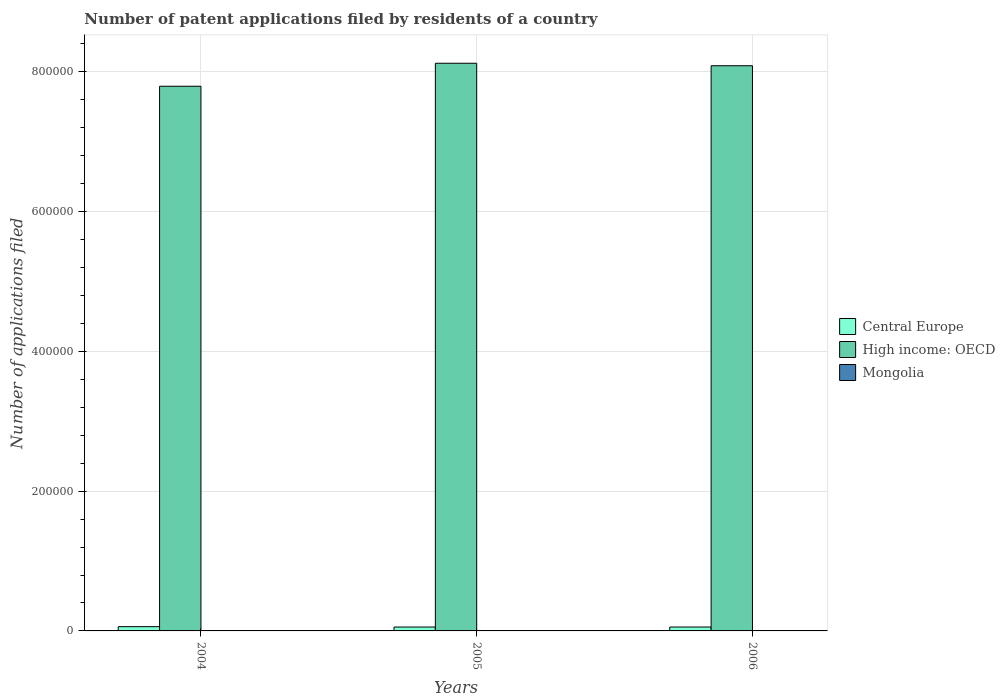How many different coloured bars are there?
Offer a very short reply. 3. How many groups of bars are there?
Provide a short and direct response. 3. Are the number of bars per tick equal to the number of legend labels?
Your response must be concise. Yes. Are the number of bars on each tick of the X-axis equal?
Give a very brief answer. Yes. How many bars are there on the 1st tick from the left?
Offer a terse response. 3. How many bars are there on the 1st tick from the right?
Your answer should be compact. 3. What is the label of the 3rd group of bars from the left?
Ensure brevity in your answer.  2006. In how many cases, is the number of bars for a given year not equal to the number of legend labels?
Provide a short and direct response. 0. What is the number of applications filed in Mongolia in 2004?
Your answer should be compact. 143. Across all years, what is the maximum number of applications filed in High income: OECD?
Your answer should be very brief. 8.12e+05. Across all years, what is the minimum number of applications filed in High income: OECD?
Your answer should be compact. 7.79e+05. In which year was the number of applications filed in Mongolia maximum?
Offer a terse response. 2004. What is the total number of applications filed in High income: OECD in the graph?
Provide a succinct answer. 2.40e+06. What is the difference between the number of applications filed in High income: OECD in 2005 and that in 2006?
Make the answer very short. 3553. What is the difference between the number of applications filed in Central Europe in 2005 and the number of applications filed in High income: OECD in 2004?
Make the answer very short. -7.74e+05. What is the average number of applications filed in High income: OECD per year?
Give a very brief answer. 8.00e+05. In the year 2006, what is the difference between the number of applications filed in High income: OECD and number of applications filed in Mongolia?
Provide a succinct answer. 8.09e+05. In how many years, is the number of applications filed in Mongolia greater than 800000?
Keep it short and to the point. 0. What is the ratio of the number of applications filed in High income: OECD in 2004 to that in 2006?
Your answer should be compact. 0.96. Is the difference between the number of applications filed in High income: OECD in 2004 and 2006 greater than the difference between the number of applications filed in Mongolia in 2004 and 2006?
Offer a terse response. No. What is the difference between the highest and the lowest number of applications filed in Central Europe?
Keep it short and to the point. 538. In how many years, is the number of applications filed in High income: OECD greater than the average number of applications filed in High income: OECD taken over all years?
Offer a terse response. 2. Is the sum of the number of applications filed in Mongolia in 2004 and 2005 greater than the maximum number of applications filed in Central Europe across all years?
Your answer should be compact. No. What does the 1st bar from the left in 2006 represents?
Offer a very short reply. Central Europe. What does the 2nd bar from the right in 2005 represents?
Provide a succinct answer. High income: OECD. Does the graph contain grids?
Offer a very short reply. Yes. Where does the legend appear in the graph?
Your answer should be compact. Center right. How many legend labels are there?
Offer a very short reply. 3. How are the legend labels stacked?
Offer a terse response. Vertical. What is the title of the graph?
Make the answer very short. Number of patent applications filed by residents of a country. Does "Lebanon" appear as one of the legend labels in the graph?
Offer a terse response. No. What is the label or title of the Y-axis?
Your answer should be very brief. Number of applications filed. What is the Number of applications filed of Central Europe in 2004?
Give a very brief answer. 6099. What is the Number of applications filed in High income: OECD in 2004?
Make the answer very short. 7.79e+05. What is the Number of applications filed in Mongolia in 2004?
Make the answer very short. 143. What is the Number of applications filed in Central Europe in 2005?
Your answer should be very brief. 5561. What is the Number of applications filed of High income: OECD in 2005?
Provide a succinct answer. 8.12e+05. What is the Number of applications filed in Mongolia in 2005?
Ensure brevity in your answer.  100. What is the Number of applications filed in Central Europe in 2006?
Offer a very short reply. 5585. What is the Number of applications filed in High income: OECD in 2006?
Offer a terse response. 8.09e+05. What is the Number of applications filed of Mongolia in 2006?
Give a very brief answer. 103. Across all years, what is the maximum Number of applications filed in Central Europe?
Give a very brief answer. 6099. Across all years, what is the maximum Number of applications filed of High income: OECD?
Give a very brief answer. 8.12e+05. Across all years, what is the maximum Number of applications filed in Mongolia?
Provide a short and direct response. 143. Across all years, what is the minimum Number of applications filed in Central Europe?
Keep it short and to the point. 5561. Across all years, what is the minimum Number of applications filed in High income: OECD?
Make the answer very short. 7.79e+05. What is the total Number of applications filed in Central Europe in the graph?
Give a very brief answer. 1.72e+04. What is the total Number of applications filed in High income: OECD in the graph?
Provide a succinct answer. 2.40e+06. What is the total Number of applications filed of Mongolia in the graph?
Keep it short and to the point. 346. What is the difference between the Number of applications filed in Central Europe in 2004 and that in 2005?
Offer a terse response. 538. What is the difference between the Number of applications filed in High income: OECD in 2004 and that in 2005?
Give a very brief answer. -3.29e+04. What is the difference between the Number of applications filed of Mongolia in 2004 and that in 2005?
Your answer should be very brief. 43. What is the difference between the Number of applications filed in Central Europe in 2004 and that in 2006?
Provide a short and direct response. 514. What is the difference between the Number of applications filed of High income: OECD in 2004 and that in 2006?
Make the answer very short. -2.93e+04. What is the difference between the Number of applications filed in High income: OECD in 2005 and that in 2006?
Provide a succinct answer. 3553. What is the difference between the Number of applications filed in Central Europe in 2004 and the Number of applications filed in High income: OECD in 2005?
Ensure brevity in your answer.  -8.06e+05. What is the difference between the Number of applications filed of Central Europe in 2004 and the Number of applications filed of Mongolia in 2005?
Your answer should be compact. 5999. What is the difference between the Number of applications filed of High income: OECD in 2004 and the Number of applications filed of Mongolia in 2005?
Offer a very short reply. 7.79e+05. What is the difference between the Number of applications filed in Central Europe in 2004 and the Number of applications filed in High income: OECD in 2006?
Offer a terse response. -8.03e+05. What is the difference between the Number of applications filed in Central Europe in 2004 and the Number of applications filed in Mongolia in 2006?
Make the answer very short. 5996. What is the difference between the Number of applications filed in High income: OECD in 2004 and the Number of applications filed in Mongolia in 2006?
Provide a short and direct response. 7.79e+05. What is the difference between the Number of applications filed in Central Europe in 2005 and the Number of applications filed in High income: OECD in 2006?
Provide a short and direct response. -8.03e+05. What is the difference between the Number of applications filed of Central Europe in 2005 and the Number of applications filed of Mongolia in 2006?
Keep it short and to the point. 5458. What is the difference between the Number of applications filed of High income: OECD in 2005 and the Number of applications filed of Mongolia in 2006?
Your answer should be compact. 8.12e+05. What is the average Number of applications filed of Central Europe per year?
Provide a short and direct response. 5748.33. What is the average Number of applications filed in High income: OECD per year?
Your answer should be compact. 8.00e+05. What is the average Number of applications filed of Mongolia per year?
Your answer should be very brief. 115.33. In the year 2004, what is the difference between the Number of applications filed in Central Europe and Number of applications filed in High income: OECD?
Offer a terse response. -7.73e+05. In the year 2004, what is the difference between the Number of applications filed of Central Europe and Number of applications filed of Mongolia?
Your answer should be compact. 5956. In the year 2004, what is the difference between the Number of applications filed of High income: OECD and Number of applications filed of Mongolia?
Offer a terse response. 7.79e+05. In the year 2005, what is the difference between the Number of applications filed of Central Europe and Number of applications filed of High income: OECD?
Make the answer very short. -8.07e+05. In the year 2005, what is the difference between the Number of applications filed of Central Europe and Number of applications filed of Mongolia?
Give a very brief answer. 5461. In the year 2005, what is the difference between the Number of applications filed of High income: OECD and Number of applications filed of Mongolia?
Make the answer very short. 8.12e+05. In the year 2006, what is the difference between the Number of applications filed in Central Europe and Number of applications filed in High income: OECD?
Offer a terse response. -8.03e+05. In the year 2006, what is the difference between the Number of applications filed in Central Europe and Number of applications filed in Mongolia?
Give a very brief answer. 5482. In the year 2006, what is the difference between the Number of applications filed in High income: OECD and Number of applications filed in Mongolia?
Make the answer very short. 8.09e+05. What is the ratio of the Number of applications filed in Central Europe in 2004 to that in 2005?
Ensure brevity in your answer.  1.1. What is the ratio of the Number of applications filed of High income: OECD in 2004 to that in 2005?
Provide a short and direct response. 0.96. What is the ratio of the Number of applications filed in Mongolia in 2004 to that in 2005?
Ensure brevity in your answer.  1.43. What is the ratio of the Number of applications filed of Central Europe in 2004 to that in 2006?
Your answer should be very brief. 1.09. What is the ratio of the Number of applications filed of High income: OECD in 2004 to that in 2006?
Provide a succinct answer. 0.96. What is the ratio of the Number of applications filed of Mongolia in 2004 to that in 2006?
Keep it short and to the point. 1.39. What is the ratio of the Number of applications filed of Central Europe in 2005 to that in 2006?
Offer a terse response. 1. What is the ratio of the Number of applications filed in High income: OECD in 2005 to that in 2006?
Provide a short and direct response. 1. What is the ratio of the Number of applications filed of Mongolia in 2005 to that in 2006?
Make the answer very short. 0.97. What is the difference between the highest and the second highest Number of applications filed in Central Europe?
Provide a succinct answer. 514. What is the difference between the highest and the second highest Number of applications filed in High income: OECD?
Make the answer very short. 3553. What is the difference between the highest and the lowest Number of applications filed in Central Europe?
Keep it short and to the point. 538. What is the difference between the highest and the lowest Number of applications filed of High income: OECD?
Offer a very short reply. 3.29e+04. What is the difference between the highest and the lowest Number of applications filed of Mongolia?
Offer a terse response. 43. 